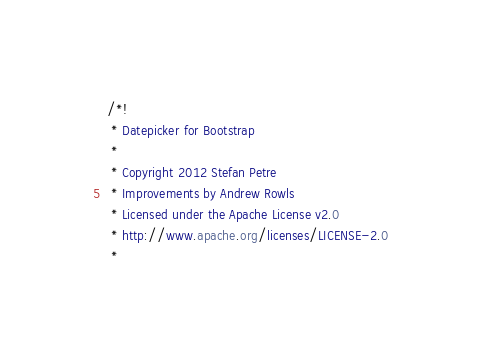<code> <loc_0><loc_0><loc_500><loc_500><_CSS_>/*!
 * Datepicker for Bootstrap
 *
 * Copyright 2012 Stefan Petre
 * Improvements by Andrew Rowls
 * Licensed under the Apache License v2.0
 * http://www.apache.org/licenses/LICENSE-2.0
 *</code> 